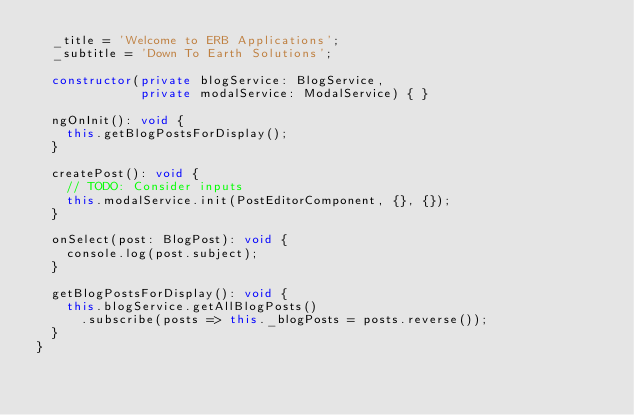Convert code to text. <code><loc_0><loc_0><loc_500><loc_500><_TypeScript_>  _title = 'Welcome to ERB Applications';
  _subtitle = 'Down To Earth Solutions';

  constructor(private blogService: BlogService,
              private modalService: ModalService) { }

  ngOnInit(): void {
    this.getBlogPostsForDisplay();
  }

  createPost(): void {
    // TODO: Consider inputs
    this.modalService.init(PostEditorComponent, {}, {});
  }

  onSelect(post: BlogPost): void {
    console.log(post.subject);
  }

  getBlogPostsForDisplay(): void {
    this.blogService.getAllBlogPosts()
      .subscribe(posts => this._blogPosts = posts.reverse());
  }
}
</code> 